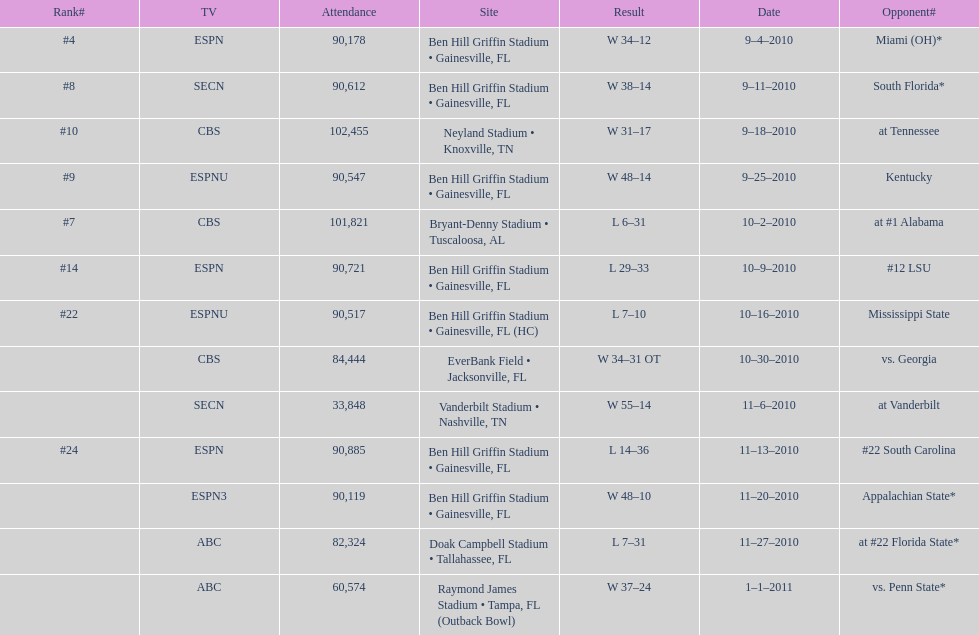How many games did the university of florida win by at least 10 points? 7. 